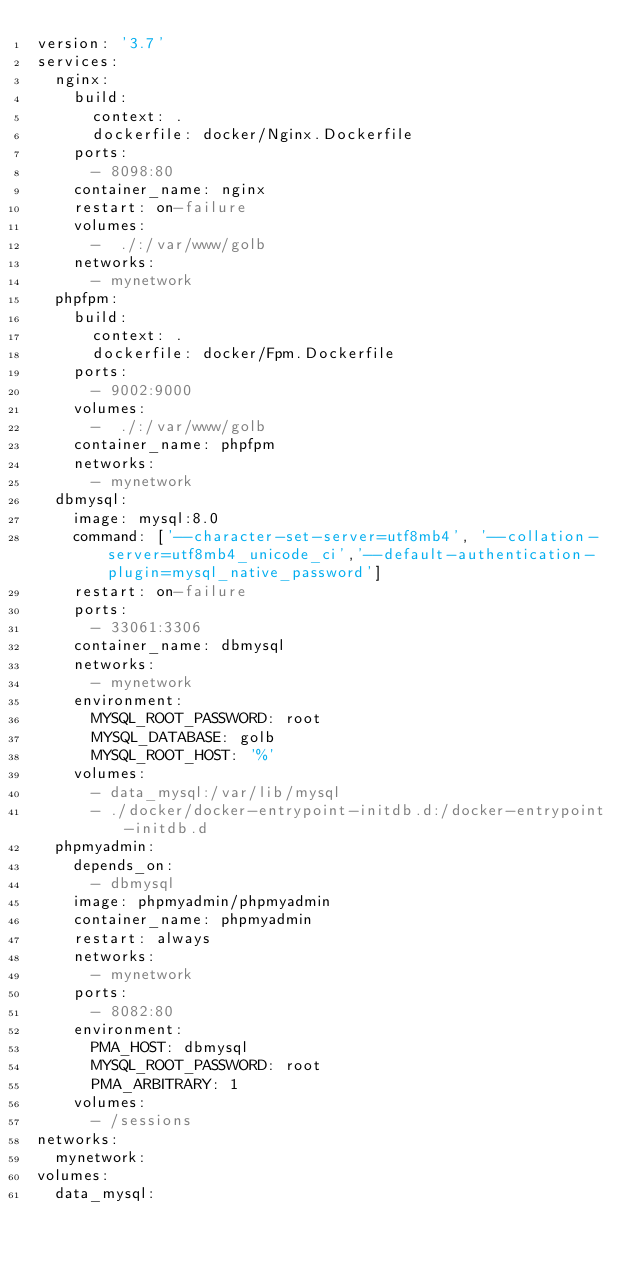<code> <loc_0><loc_0><loc_500><loc_500><_YAML_>version: '3.7'
services:
  nginx:
    build:
      context: .
      dockerfile: docker/Nginx.Dockerfile
    ports:
      - 8098:80
    container_name: nginx
    restart: on-failure
    volumes:
      -  ./:/var/www/golb
    networks:
      - mynetwork
  phpfpm:
    build:
      context: .
      dockerfile: docker/Fpm.Dockerfile
    ports:
      - 9002:9000
    volumes:
      -  ./:/var/www/golb
    container_name: phpfpm
    networks:
      - mynetwork
  dbmysql:
    image: mysql:8.0
    command: ['--character-set-server=utf8mb4', '--collation-server=utf8mb4_unicode_ci','--default-authentication-plugin=mysql_native_password']
    restart: on-failure
    ports:
      - 33061:3306
    container_name: dbmysql
    networks:
      - mynetwork
    environment:
      MYSQL_ROOT_PASSWORD: root
      MYSQL_DATABASE: golb
      MYSQL_ROOT_HOST: '%'
    volumes:
      - data_mysql:/var/lib/mysql
      - ./docker/docker-entrypoint-initdb.d:/docker-entrypoint-initdb.d
  phpmyadmin:
    depends_on:
      - dbmysql
    image: phpmyadmin/phpmyadmin
    container_name: phpmyadmin
    restart: always
    networks:
      - mynetwork
    ports:
      - 8082:80
    environment:
      PMA_HOST: dbmysql
      MYSQL_ROOT_PASSWORD: root
      PMA_ARBITRARY: 1
    volumes:
      - /sessions
networks:
  mynetwork:
volumes:
  data_mysql:
</code> 